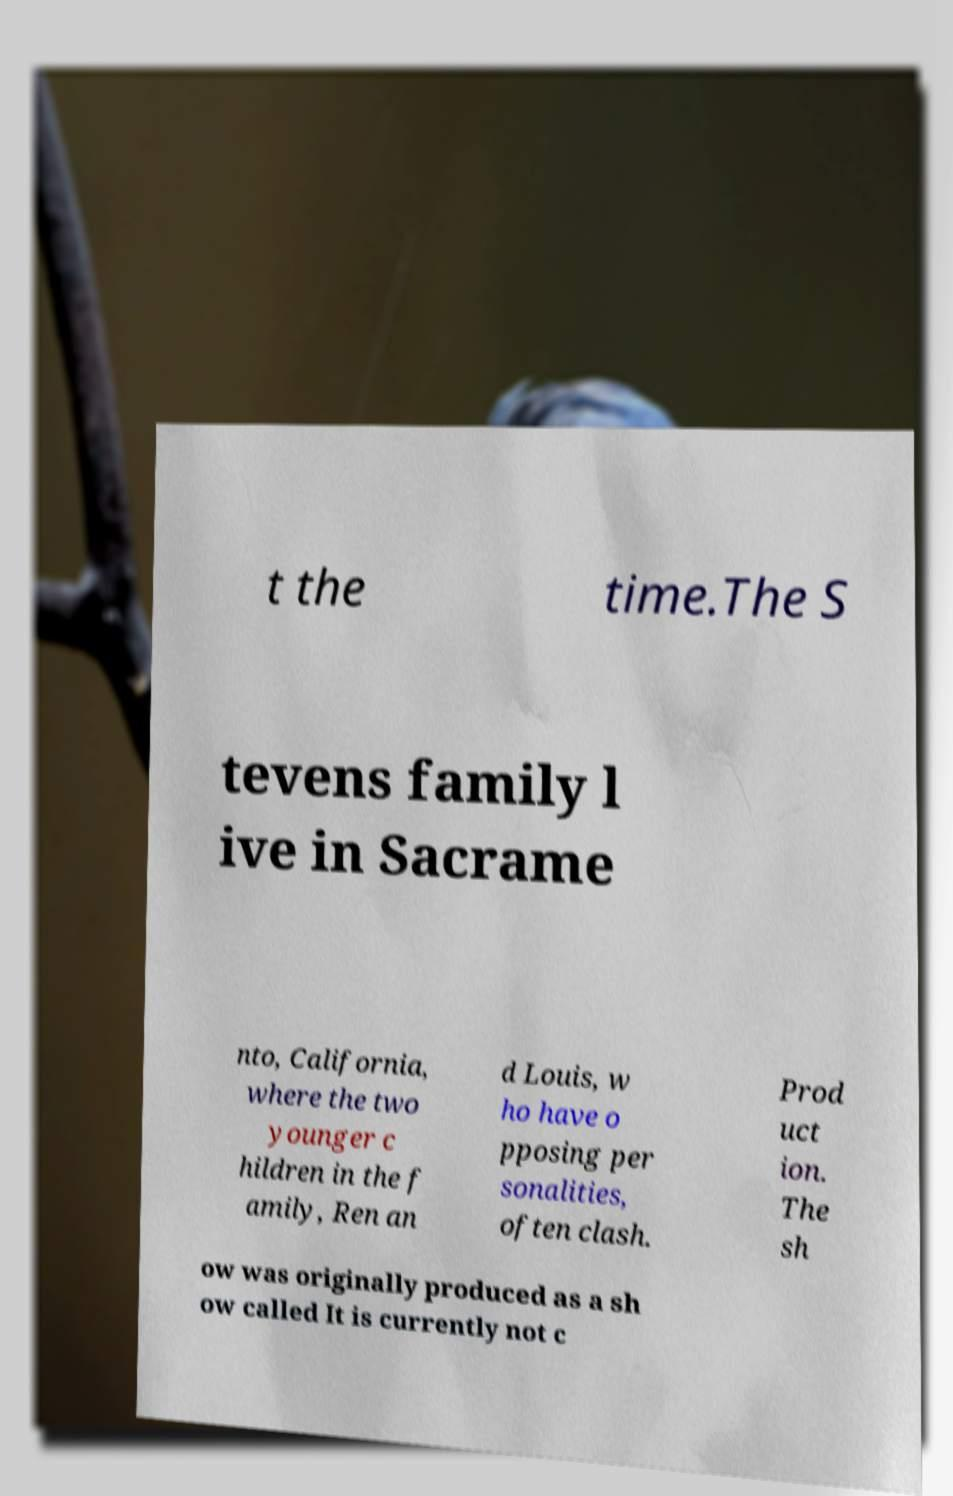Can you read and provide the text displayed in the image?This photo seems to have some interesting text. Can you extract and type it out for me? t the time.The S tevens family l ive in Sacrame nto, California, where the two younger c hildren in the f amily, Ren an d Louis, w ho have o pposing per sonalities, often clash. Prod uct ion. The sh ow was originally produced as a sh ow called It is currently not c 